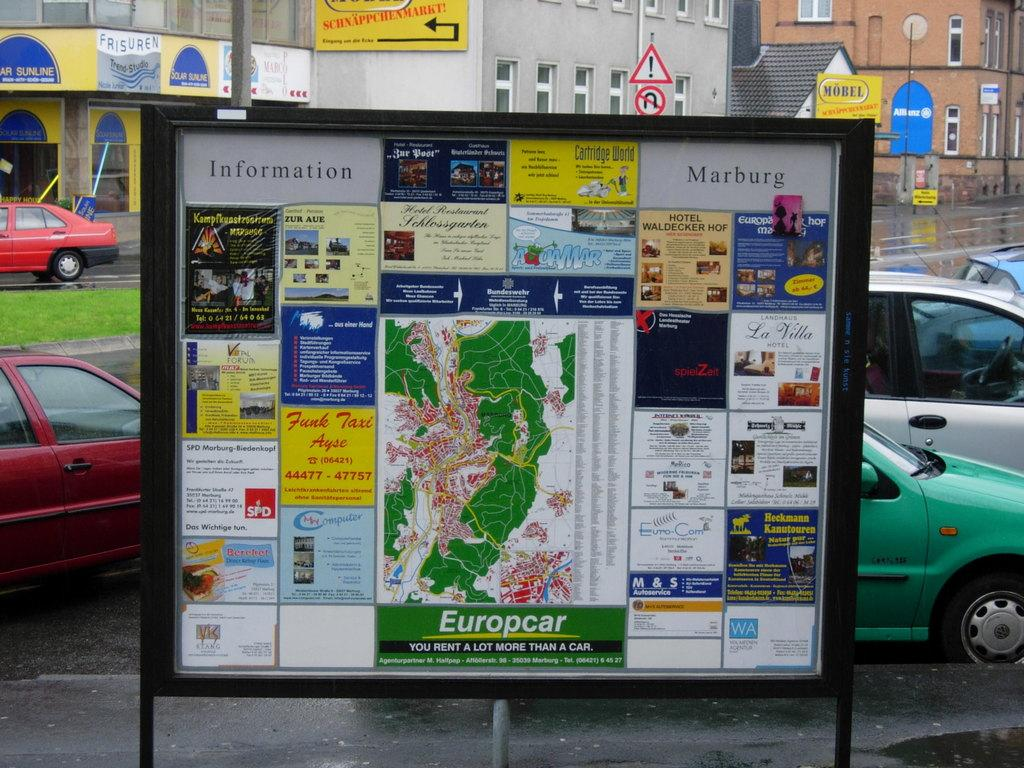<image>
Give a short and clear explanation of the subsequent image. A map surrounded by parked cars says Europcar. 